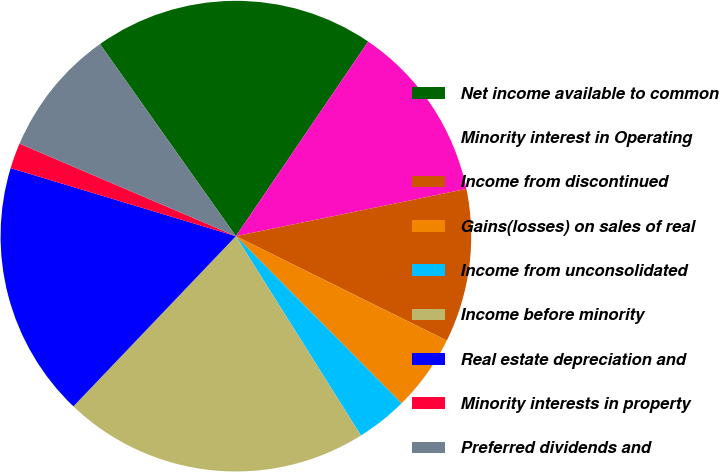Convert chart to OTSL. <chart><loc_0><loc_0><loc_500><loc_500><pie_chart><fcel>Net income available to common<fcel>Minority interest in Operating<fcel>Income from discontinued<fcel>Gains(losses) on sales of real<fcel>Income from unconsolidated<fcel>Income before minority<fcel>Real estate depreciation and<fcel>Minority interests in property<fcel>Preferred dividends and<nl><fcel>19.3%<fcel>12.28%<fcel>10.53%<fcel>5.26%<fcel>3.51%<fcel>21.05%<fcel>17.54%<fcel>1.76%<fcel>8.77%<nl></chart> 